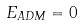Convert formula to latex. <formula><loc_0><loc_0><loc_500><loc_500>E _ { A D M } = 0</formula> 